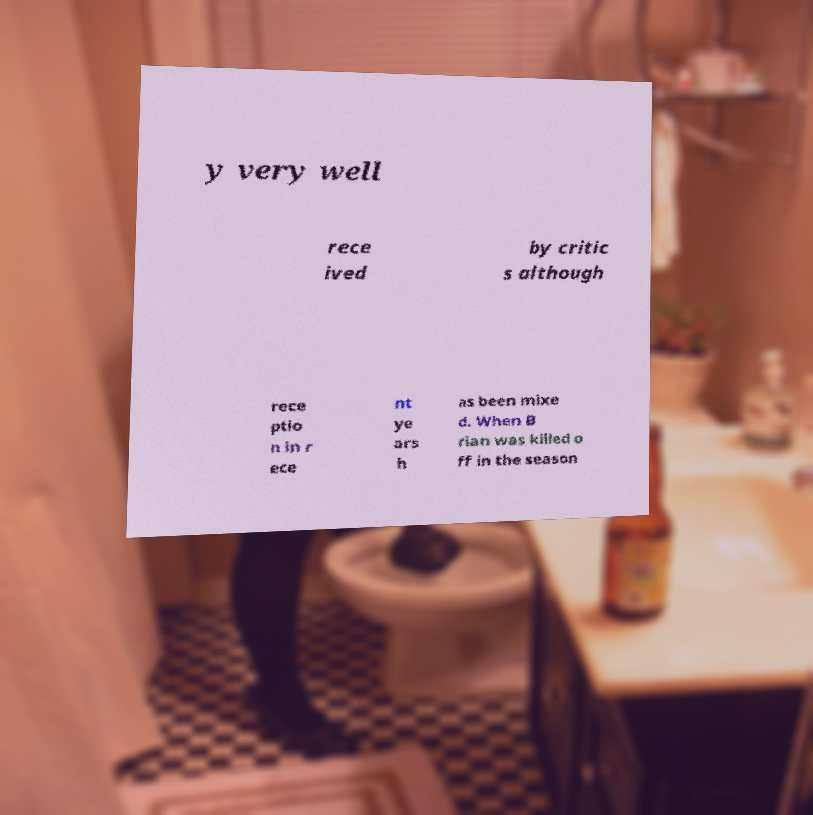Can you accurately transcribe the text from the provided image for me? y very well rece ived by critic s although rece ptio n in r ece nt ye ars h as been mixe d. When B rian was killed o ff in the season 